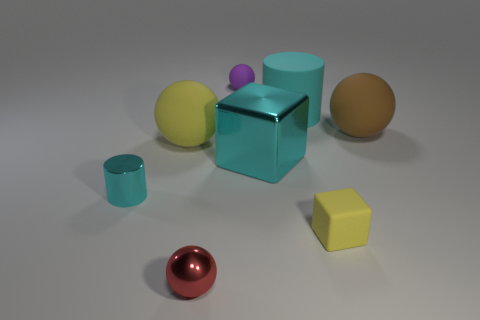Subtract all small purple balls. How many balls are left? 3 Subtract all brown balls. How many balls are left? 3 Add 1 small red metal balls. How many objects exist? 9 Subtract all cylinders. How many objects are left? 6 Subtract 0 brown blocks. How many objects are left? 8 Subtract all brown blocks. Subtract all purple cylinders. How many blocks are left? 2 Subtract all small purple rubber balls. Subtract all brown balls. How many objects are left? 6 Add 8 yellow cubes. How many yellow cubes are left? 9 Add 3 yellow cubes. How many yellow cubes exist? 4 